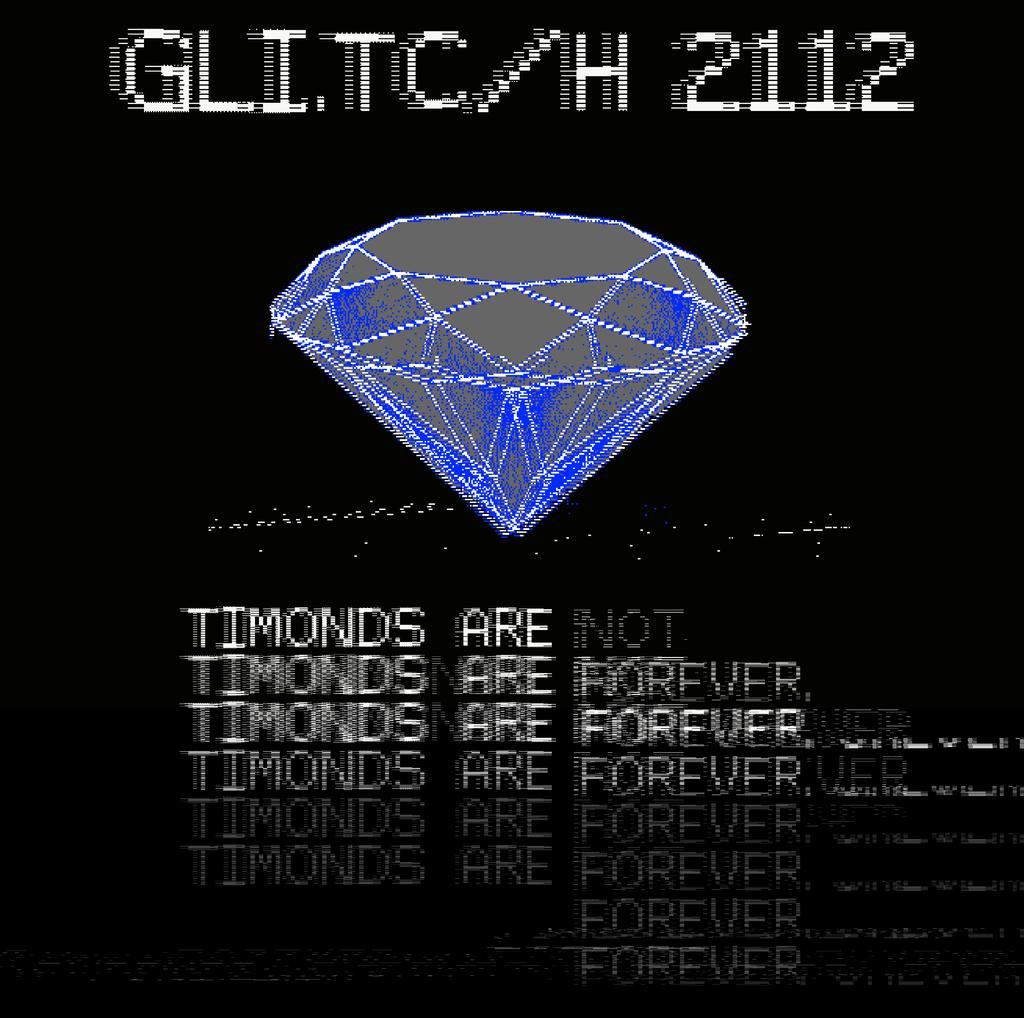<image>
Relay a brief, clear account of the picture shown. A messed up looking computer screen that says Timonds are not forever. 